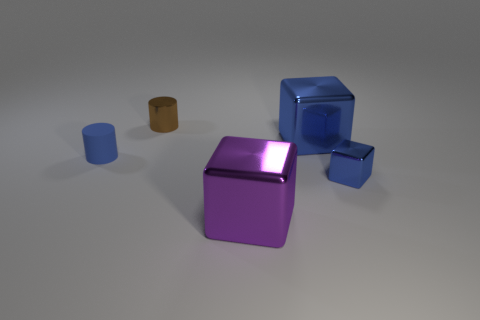Add 5 purple metallic cubes. How many objects exist? 10 Subtract all blocks. How many objects are left? 2 Add 3 tiny brown rubber cylinders. How many tiny brown rubber cylinders exist? 3 Subtract 0 red cylinders. How many objects are left? 5 Subtract all tiny matte things. Subtract all brown cylinders. How many objects are left? 3 Add 3 small brown metallic things. How many small brown metallic things are left? 4 